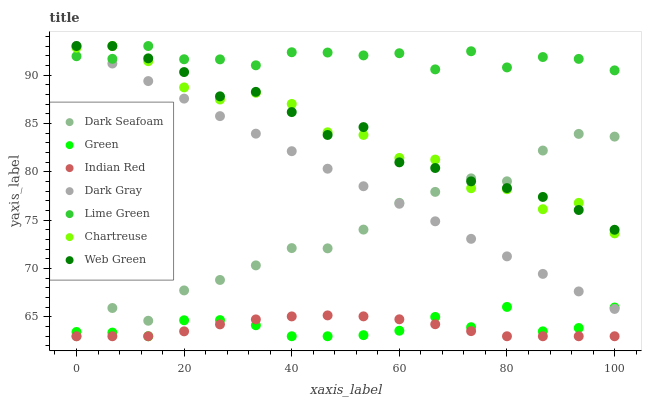Does Indian Red have the minimum area under the curve?
Answer yes or no. Yes. Does Lime Green have the maximum area under the curve?
Answer yes or no. Yes. Does Web Green have the minimum area under the curve?
Answer yes or no. No. Does Web Green have the maximum area under the curve?
Answer yes or no. No. Is Dark Gray the smoothest?
Answer yes or no. Yes. Is Chartreuse the roughest?
Answer yes or no. Yes. Is Web Green the smoothest?
Answer yes or no. No. Is Web Green the roughest?
Answer yes or no. No. Does Dark Seafoam have the lowest value?
Answer yes or no. Yes. Does Web Green have the lowest value?
Answer yes or no. No. Does Lime Green have the highest value?
Answer yes or no. Yes. Does Dark Seafoam have the highest value?
Answer yes or no. No. Is Indian Red less than Chartreuse?
Answer yes or no. Yes. Is Dark Gray greater than Indian Red?
Answer yes or no. Yes. Does Dark Gray intersect Lime Green?
Answer yes or no. Yes. Is Dark Gray less than Lime Green?
Answer yes or no. No. Is Dark Gray greater than Lime Green?
Answer yes or no. No. Does Indian Red intersect Chartreuse?
Answer yes or no. No. 